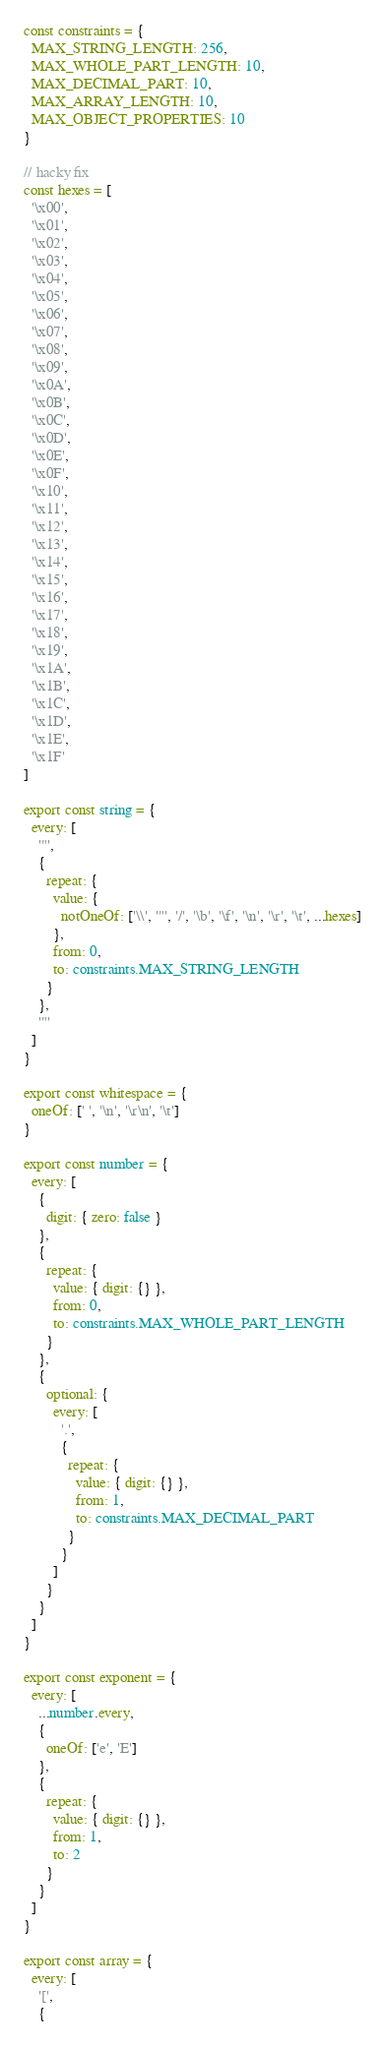<code> <loc_0><loc_0><loc_500><loc_500><_TypeScript_>
const constraints = {
  MAX_STRING_LENGTH: 256,
  MAX_WHOLE_PART_LENGTH: 10,
  MAX_DECIMAL_PART: 10,
  MAX_ARRAY_LENGTH: 10,
  MAX_OBJECT_PROPERTIES: 10
}

// hacky fix
const hexes = [
  '\x00',
  '\x01',
  '\x02',
  '\x03',
  '\x04',
  '\x05',
  '\x06',
  '\x07',
  '\x08',
  '\x09',
  '\x0A',
  '\x0B',
  '\x0C',
  '\x0D',
  '\x0E',
  '\x0F',
  '\x10',
  '\x11',
  '\x12',
  '\x13',
  '\x14',
  '\x15',
  '\x16',
  '\x17',
  '\x18',
  '\x19',
  '\x1A',
  '\x1B',
  '\x1C',
  '\x1D',
  '\x1E',
  '\x1F'
]

export const string = {
  every: [
    '"',
    {
      repeat: {
        value: {
          notOneOf: ['\\', '"', '/', '\b', '\f', '\n', '\r', '\t', ...hexes]
        },
        from: 0,
        to: constraints.MAX_STRING_LENGTH
      }
    },
    '"'
  ]
}

export const whitespace = {
  oneOf: [' ', '\n', '\r\n', '\t']
}

export const number = {
  every: [
    {
      digit: { zero: false }
    },
    {
      repeat: {
        value: { digit: {} },
        from: 0,
        to: constraints.MAX_WHOLE_PART_LENGTH
      }
    },
    {
      optional: {
        every: [
          '.',
          {
            repeat: {
              value: { digit: {} },
              from: 1,
              to: constraints.MAX_DECIMAL_PART
            }
          }
        ]
      }
    }
  ]
}

export const exponent = {
  every: [
    ...number.every,
    {
      oneOf: ['e', 'E']
    },
    {
      repeat: {
        value: { digit: {} },
        from: 1,
        to: 2
      }
    }
  ]
}

export const array = {
  every: [
    '[',
    {</code> 